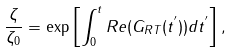Convert formula to latex. <formula><loc_0><loc_0><loc_500><loc_500>\frac { \zeta } { \zeta _ { 0 } } = \exp \left [ \int _ { 0 } ^ { t } R e ( G _ { R T } ( t ^ { ^ { \prime } } ) ) d t ^ { ^ { \prime } } \right ] ,</formula> 